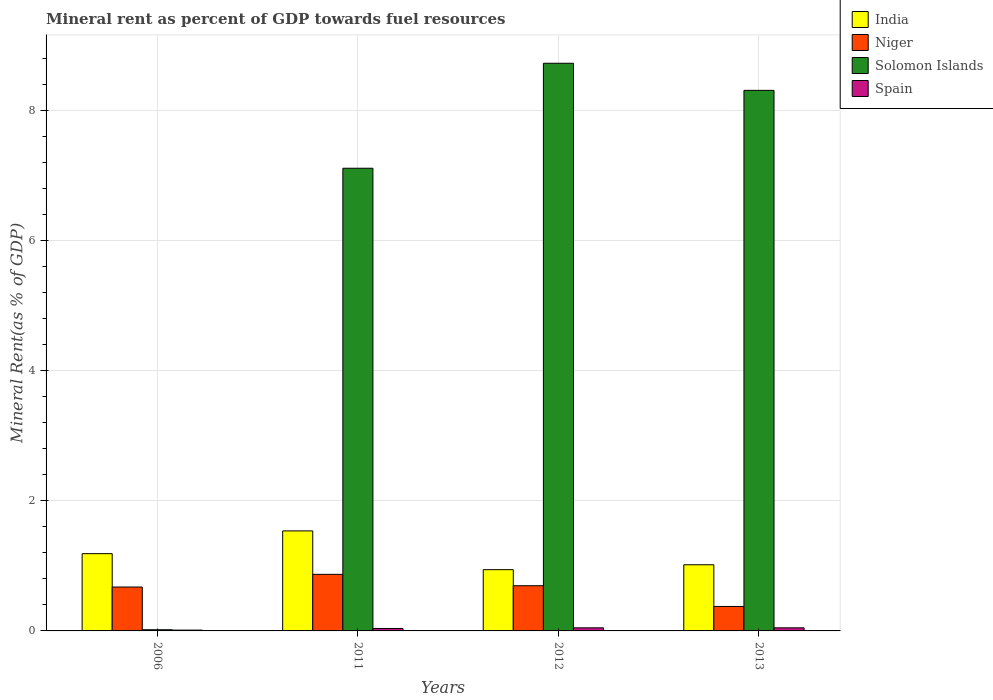How many bars are there on the 1st tick from the left?
Provide a succinct answer. 4. What is the label of the 2nd group of bars from the left?
Provide a succinct answer. 2011. In how many cases, is the number of bars for a given year not equal to the number of legend labels?
Your answer should be very brief. 0. What is the mineral rent in India in 2013?
Your answer should be very brief. 1.02. Across all years, what is the maximum mineral rent in Niger?
Your response must be concise. 0.87. Across all years, what is the minimum mineral rent in Spain?
Your answer should be compact. 0.01. In which year was the mineral rent in Niger minimum?
Provide a short and direct response. 2013. What is the total mineral rent in Niger in the graph?
Provide a short and direct response. 2.62. What is the difference between the mineral rent in Niger in 2012 and that in 2013?
Offer a very short reply. 0.32. What is the difference between the mineral rent in India in 2012 and the mineral rent in Niger in 2013?
Offer a terse response. 0.57. What is the average mineral rent in Niger per year?
Provide a short and direct response. 0.65. In the year 2012, what is the difference between the mineral rent in India and mineral rent in Niger?
Your response must be concise. 0.25. What is the ratio of the mineral rent in Niger in 2006 to that in 2011?
Keep it short and to the point. 0.78. Is the mineral rent in India in 2006 less than that in 2011?
Offer a very short reply. Yes. What is the difference between the highest and the second highest mineral rent in Spain?
Provide a succinct answer. 0. What is the difference between the highest and the lowest mineral rent in Solomon Islands?
Offer a very short reply. 8.71. Is the sum of the mineral rent in India in 2006 and 2013 greater than the maximum mineral rent in Solomon Islands across all years?
Your answer should be very brief. No. Is it the case that in every year, the sum of the mineral rent in Spain and mineral rent in Solomon Islands is greater than the sum of mineral rent in Niger and mineral rent in India?
Make the answer very short. No. What does the 3rd bar from the left in 2006 represents?
Make the answer very short. Solomon Islands. Are all the bars in the graph horizontal?
Ensure brevity in your answer.  No. How many years are there in the graph?
Provide a succinct answer. 4. Are the values on the major ticks of Y-axis written in scientific E-notation?
Your answer should be very brief. No. Does the graph contain grids?
Offer a terse response. Yes. What is the title of the graph?
Ensure brevity in your answer.  Mineral rent as percent of GDP towards fuel resources. Does "Cote d'Ivoire" appear as one of the legend labels in the graph?
Provide a succinct answer. No. What is the label or title of the Y-axis?
Give a very brief answer. Mineral Rent(as % of GDP). What is the Mineral Rent(as % of GDP) in India in 2006?
Ensure brevity in your answer.  1.19. What is the Mineral Rent(as % of GDP) of Niger in 2006?
Your response must be concise. 0.68. What is the Mineral Rent(as % of GDP) of Solomon Islands in 2006?
Your response must be concise. 0.02. What is the Mineral Rent(as % of GDP) in Spain in 2006?
Your response must be concise. 0.01. What is the Mineral Rent(as % of GDP) of India in 2011?
Your answer should be very brief. 1.54. What is the Mineral Rent(as % of GDP) of Niger in 2011?
Provide a succinct answer. 0.87. What is the Mineral Rent(as % of GDP) in Solomon Islands in 2011?
Your answer should be very brief. 7.12. What is the Mineral Rent(as % of GDP) of Spain in 2011?
Offer a terse response. 0.04. What is the Mineral Rent(as % of GDP) in India in 2012?
Offer a terse response. 0.94. What is the Mineral Rent(as % of GDP) of Niger in 2012?
Ensure brevity in your answer.  0.69. What is the Mineral Rent(as % of GDP) in Solomon Islands in 2012?
Offer a very short reply. 8.73. What is the Mineral Rent(as % of GDP) in Spain in 2012?
Keep it short and to the point. 0.05. What is the Mineral Rent(as % of GDP) of India in 2013?
Your answer should be compact. 1.02. What is the Mineral Rent(as % of GDP) in Niger in 2013?
Offer a terse response. 0.38. What is the Mineral Rent(as % of GDP) of Solomon Islands in 2013?
Offer a terse response. 8.31. What is the Mineral Rent(as % of GDP) in Spain in 2013?
Ensure brevity in your answer.  0.05. Across all years, what is the maximum Mineral Rent(as % of GDP) in India?
Keep it short and to the point. 1.54. Across all years, what is the maximum Mineral Rent(as % of GDP) of Niger?
Give a very brief answer. 0.87. Across all years, what is the maximum Mineral Rent(as % of GDP) of Solomon Islands?
Provide a succinct answer. 8.73. Across all years, what is the maximum Mineral Rent(as % of GDP) in Spain?
Give a very brief answer. 0.05. Across all years, what is the minimum Mineral Rent(as % of GDP) in India?
Offer a terse response. 0.94. Across all years, what is the minimum Mineral Rent(as % of GDP) of Niger?
Give a very brief answer. 0.38. Across all years, what is the minimum Mineral Rent(as % of GDP) of Solomon Islands?
Your answer should be very brief. 0.02. Across all years, what is the minimum Mineral Rent(as % of GDP) of Spain?
Ensure brevity in your answer.  0.01. What is the total Mineral Rent(as % of GDP) of India in the graph?
Keep it short and to the point. 4.69. What is the total Mineral Rent(as % of GDP) of Niger in the graph?
Offer a very short reply. 2.62. What is the total Mineral Rent(as % of GDP) in Solomon Islands in the graph?
Your answer should be very brief. 24.18. What is the total Mineral Rent(as % of GDP) of Spain in the graph?
Offer a terse response. 0.15. What is the difference between the Mineral Rent(as % of GDP) of India in 2006 and that in 2011?
Provide a short and direct response. -0.35. What is the difference between the Mineral Rent(as % of GDP) in Niger in 2006 and that in 2011?
Your response must be concise. -0.2. What is the difference between the Mineral Rent(as % of GDP) of Solomon Islands in 2006 and that in 2011?
Ensure brevity in your answer.  -7.1. What is the difference between the Mineral Rent(as % of GDP) of Spain in 2006 and that in 2011?
Your response must be concise. -0.03. What is the difference between the Mineral Rent(as % of GDP) in India in 2006 and that in 2012?
Provide a short and direct response. 0.25. What is the difference between the Mineral Rent(as % of GDP) in Niger in 2006 and that in 2012?
Provide a succinct answer. -0.02. What is the difference between the Mineral Rent(as % of GDP) of Solomon Islands in 2006 and that in 2012?
Your answer should be very brief. -8.71. What is the difference between the Mineral Rent(as % of GDP) in Spain in 2006 and that in 2012?
Offer a terse response. -0.04. What is the difference between the Mineral Rent(as % of GDP) in India in 2006 and that in 2013?
Your answer should be very brief. 0.17. What is the difference between the Mineral Rent(as % of GDP) in Niger in 2006 and that in 2013?
Offer a terse response. 0.3. What is the difference between the Mineral Rent(as % of GDP) in Solomon Islands in 2006 and that in 2013?
Your response must be concise. -8.3. What is the difference between the Mineral Rent(as % of GDP) in Spain in 2006 and that in 2013?
Offer a terse response. -0.03. What is the difference between the Mineral Rent(as % of GDP) of India in 2011 and that in 2012?
Your answer should be compact. 0.6. What is the difference between the Mineral Rent(as % of GDP) of Niger in 2011 and that in 2012?
Provide a succinct answer. 0.18. What is the difference between the Mineral Rent(as % of GDP) of Solomon Islands in 2011 and that in 2012?
Give a very brief answer. -1.61. What is the difference between the Mineral Rent(as % of GDP) of Spain in 2011 and that in 2012?
Provide a short and direct response. -0.01. What is the difference between the Mineral Rent(as % of GDP) of India in 2011 and that in 2013?
Provide a short and direct response. 0.52. What is the difference between the Mineral Rent(as % of GDP) of Niger in 2011 and that in 2013?
Ensure brevity in your answer.  0.49. What is the difference between the Mineral Rent(as % of GDP) of Solomon Islands in 2011 and that in 2013?
Offer a very short reply. -1.2. What is the difference between the Mineral Rent(as % of GDP) in Spain in 2011 and that in 2013?
Provide a short and direct response. -0.01. What is the difference between the Mineral Rent(as % of GDP) in India in 2012 and that in 2013?
Your answer should be compact. -0.08. What is the difference between the Mineral Rent(as % of GDP) of Niger in 2012 and that in 2013?
Offer a terse response. 0.32. What is the difference between the Mineral Rent(as % of GDP) of Solomon Islands in 2012 and that in 2013?
Make the answer very short. 0.42. What is the difference between the Mineral Rent(as % of GDP) in India in 2006 and the Mineral Rent(as % of GDP) in Niger in 2011?
Ensure brevity in your answer.  0.32. What is the difference between the Mineral Rent(as % of GDP) in India in 2006 and the Mineral Rent(as % of GDP) in Solomon Islands in 2011?
Make the answer very short. -5.93. What is the difference between the Mineral Rent(as % of GDP) in India in 2006 and the Mineral Rent(as % of GDP) in Spain in 2011?
Offer a terse response. 1.15. What is the difference between the Mineral Rent(as % of GDP) of Niger in 2006 and the Mineral Rent(as % of GDP) of Solomon Islands in 2011?
Provide a short and direct response. -6.44. What is the difference between the Mineral Rent(as % of GDP) in Niger in 2006 and the Mineral Rent(as % of GDP) in Spain in 2011?
Your answer should be compact. 0.64. What is the difference between the Mineral Rent(as % of GDP) in Solomon Islands in 2006 and the Mineral Rent(as % of GDP) in Spain in 2011?
Offer a terse response. -0.02. What is the difference between the Mineral Rent(as % of GDP) in India in 2006 and the Mineral Rent(as % of GDP) in Niger in 2012?
Offer a terse response. 0.49. What is the difference between the Mineral Rent(as % of GDP) in India in 2006 and the Mineral Rent(as % of GDP) in Solomon Islands in 2012?
Give a very brief answer. -7.54. What is the difference between the Mineral Rent(as % of GDP) of India in 2006 and the Mineral Rent(as % of GDP) of Spain in 2012?
Ensure brevity in your answer.  1.14. What is the difference between the Mineral Rent(as % of GDP) in Niger in 2006 and the Mineral Rent(as % of GDP) in Solomon Islands in 2012?
Provide a succinct answer. -8.06. What is the difference between the Mineral Rent(as % of GDP) in Niger in 2006 and the Mineral Rent(as % of GDP) in Spain in 2012?
Give a very brief answer. 0.63. What is the difference between the Mineral Rent(as % of GDP) of Solomon Islands in 2006 and the Mineral Rent(as % of GDP) of Spain in 2012?
Your answer should be very brief. -0.03. What is the difference between the Mineral Rent(as % of GDP) in India in 2006 and the Mineral Rent(as % of GDP) in Niger in 2013?
Your response must be concise. 0.81. What is the difference between the Mineral Rent(as % of GDP) of India in 2006 and the Mineral Rent(as % of GDP) of Solomon Islands in 2013?
Provide a short and direct response. -7.13. What is the difference between the Mineral Rent(as % of GDP) in India in 2006 and the Mineral Rent(as % of GDP) in Spain in 2013?
Offer a terse response. 1.14. What is the difference between the Mineral Rent(as % of GDP) of Niger in 2006 and the Mineral Rent(as % of GDP) of Solomon Islands in 2013?
Your answer should be very brief. -7.64. What is the difference between the Mineral Rent(as % of GDP) in Niger in 2006 and the Mineral Rent(as % of GDP) in Spain in 2013?
Your answer should be compact. 0.63. What is the difference between the Mineral Rent(as % of GDP) of Solomon Islands in 2006 and the Mineral Rent(as % of GDP) of Spain in 2013?
Your response must be concise. -0.03. What is the difference between the Mineral Rent(as % of GDP) of India in 2011 and the Mineral Rent(as % of GDP) of Niger in 2012?
Give a very brief answer. 0.84. What is the difference between the Mineral Rent(as % of GDP) in India in 2011 and the Mineral Rent(as % of GDP) in Solomon Islands in 2012?
Your answer should be compact. -7.19. What is the difference between the Mineral Rent(as % of GDP) in India in 2011 and the Mineral Rent(as % of GDP) in Spain in 2012?
Keep it short and to the point. 1.49. What is the difference between the Mineral Rent(as % of GDP) of Niger in 2011 and the Mineral Rent(as % of GDP) of Solomon Islands in 2012?
Your answer should be compact. -7.86. What is the difference between the Mineral Rent(as % of GDP) in Niger in 2011 and the Mineral Rent(as % of GDP) in Spain in 2012?
Offer a very short reply. 0.82. What is the difference between the Mineral Rent(as % of GDP) in Solomon Islands in 2011 and the Mineral Rent(as % of GDP) in Spain in 2012?
Your response must be concise. 7.07. What is the difference between the Mineral Rent(as % of GDP) in India in 2011 and the Mineral Rent(as % of GDP) in Niger in 2013?
Offer a terse response. 1.16. What is the difference between the Mineral Rent(as % of GDP) in India in 2011 and the Mineral Rent(as % of GDP) in Solomon Islands in 2013?
Offer a very short reply. -6.78. What is the difference between the Mineral Rent(as % of GDP) in India in 2011 and the Mineral Rent(as % of GDP) in Spain in 2013?
Offer a very short reply. 1.49. What is the difference between the Mineral Rent(as % of GDP) of Niger in 2011 and the Mineral Rent(as % of GDP) of Solomon Islands in 2013?
Make the answer very short. -7.44. What is the difference between the Mineral Rent(as % of GDP) of Niger in 2011 and the Mineral Rent(as % of GDP) of Spain in 2013?
Provide a short and direct response. 0.82. What is the difference between the Mineral Rent(as % of GDP) of Solomon Islands in 2011 and the Mineral Rent(as % of GDP) of Spain in 2013?
Offer a terse response. 7.07. What is the difference between the Mineral Rent(as % of GDP) of India in 2012 and the Mineral Rent(as % of GDP) of Niger in 2013?
Keep it short and to the point. 0.57. What is the difference between the Mineral Rent(as % of GDP) of India in 2012 and the Mineral Rent(as % of GDP) of Solomon Islands in 2013?
Provide a succinct answer. -7.37. What is the difference between the Mineral Rent(as % of GDP) in India in 2012 and the Mineral Rent(as % of GDP) in Spain in 2013?
Your response must be concise. 0.89. What is the difference between the Mineral Rent(as % of GDP) in Niger in 2012 and the Mineral Rent(as % of GDP) in Solomon Islands in 2013?
Keep it short and to the point. -7.62. What is the difference between the Mineral Rent(as % of GDP) in Niger in 2012 and the Mineral Rent(as % of GDP) in Spain in 2013?
Provide a short and direct response. 0.65. What is the difference between the Mineral Rent(as % of GDP) of Solomon Islands in 2012 and the Mineral Rent(as % of GDP) of Spain in 2013?
Provide a succinct answer. 8.68. What is the average Mineral Rent(as % of GDP) in India per year?
Provide a short and direct response. 1.17. What is the average Mineral Rent(as % of GDP) in Niger per year?
Your answer should be very brief. 0.65. What is the average Mineral Rent(as % of GDP) of Solomon Islands per year?
Make the answer very short. 6.04. What is the average Mineral Rent(as % of GDP) in Spain per year?
Ensure brevity in your answer.  0.04. In the year 2006, what is the difference between the Mineral Rent(as % of GDP) of India and Mineral Rent(as % of GDP) of Niger?
Provide a short and direct response. 0.51. In the year 2006, what is the difference between the Mineral Rent(as % of GDP) in India and Mineral Rent(as % of GDP) in Solomon Islands?
Your answer should be compact. 1.17. In the year 2006, what is the difference between the Mineral Rent(as % of GDP) in India and Mineral Rent(as % of GDP) in Spain?
Your answer should be compact. 1.18. In the year 2006, what is the difference between the Mineral Rent(as % of GDP) of Niger and Mineral Rent(as % of GDP) of Solomon Islands?
Give a very brief answer. 0.66. In the year 2006, what is the difference between the Mineral Rent(as % of GDP) in Niger and Mineral Rent(as % of GDP) in Spain?
Ensure brevity in your answer.  0.66. In the year 2006, what is the difference between the Mineral Rent(as % of GDP) in Solomon Islands and Mineral Rent(as % of GDP) in Spain?
Give a very brief answer. 0.01. In the year 2011, what is the difference between the Mineral Rent(as % of GDP) in India and Mineral Rent(as % of GDP) in Niger?
Provide a short and direct response. 0.67. In the year 2011, what is the difference between the Mineral Rent(as % of GDP) in India and Mineral Rent(as % of GDP) in Solomon Islands?
Make the answer very short. -5.58. In the year 2011, what is the difference between the Mineral Rent(as % of GDP) in India and Mineral Rent(as % of GDP) in Spain?
Keep it short and to the point. 1.5. In the year 2011, what is the difference between the Mineral Rent(as % of GDP) in Niger and Mineral Rent(as % of GDP) in Solomon Islands?
Offer a very short reply. -6.25. In the year 2011, what is the difference between the Mineral Rent(as % of GDP) in Niger and Mineral Rent(as % of GDP) in Spain?
Your response must be concise. 0.83. In the year 2011, what is the difference between the Mineral Rent(as % of GDP) in Solomon Islands and Mineral Rent(as % of GDP) in Spain?
Your response must be concise. 7.08. In the year 2012, what is the difference between the Mineral Rent(as % of GDP) of India and Mineral Rent(as % of GDP) of Niger?
Offer a terse response. 0.25. In the year 2012, what is the difference between the Mineral Rent(as % of GDP) of India and Mineral Rent(as % of GDP) of Solomon Islands?
Keep it short and to the point. -7.79. In the year 2012, what is the difference between the Mineral Rent(as % of GDP) in India and Mineral Rent(as % of GDP) in Spain?
Ensure brevity in your answer.  0.89. In the year 2012, what is the difference between the Mineral Rent(as % of GDP) of Niger and Mineral Rent(as % of GDP) of Solomon Islands?
Your answer should be compact. -8.04. In the year 2012, what is the difference between the Mineral Rent(as % of GDP) of Niger and Mineral Rent(as % of GDP) of Spain?
Keep it short and to the point. 0.65. In the year 2012, what is the difference between the Mineral Rent(as % of GDP) of Solomon Islands and Mineral Rent(as % of GDP) of Spain?
Provide a short and direct response. 8.68. In the year 2013, what is the difference between the Mineral Rent(as % of GDP) in India and Mineral Rent(as % of GDP) in Niger?
Ensure brevity in your answer.  0.64. In the year 2013, what is the difference between the Mineral Rent(as % of GDP) in India and Mineral Rent(as % of GDP) in Solomon Islands?
Provide a succinct answer. -7.3. In the year 2013, what is the difference between the Mineral Rent(as % of GDP) of India and Mineral Rent(as % of GDP) of Spain?
Provide a short and direct response. 0.97. In the year 2013, what is the difference between the Mineral Rent(as % of GDP) in Niger and Mineral Rent(as % of GDP) in Solomon Islands?
Your answer should be very brief. -7.94. In the year 2013, what is the difference between the Mineral Rent(as % of GDP) in Niger and Mineral Rent(as % of GDP) in Spain?
Give a very brief answer. 0.33. In the year 2013, what is the difference between the Mineral Rent(as % of GDP) in Solomon Islands and Mineral Rent(as % of GDP) in Spain?
Keep it short and to the point. 8.27. What is the ratio of the Mineral Rent(as % of GDP) of India in 2006 to that in 2011?
Give a very brief answer. 0.77. What is the ratio of the Mineral Rent(as % of GDP) in Niger in 2006 to that in 2011?
Your response must be concise. 0.78. What is the ratio of the Mineral Rent(as % of GDP) of Solomon Islands in 2006 to that in 2011?
Offer a terse response. 0. What is the ratio of the Mineral Rent(as % of GDP) of Spain in 2006 to that in 2011?
Your response must be concise. 0.33. What is the ratio of the Mineral Rent(as % of GDP) of India in 2006 to that in 2012?
Give a very brief answer. 1.26. What is the ratio of the Mineral Rent(as % of GDP) of Niger in 2006 to that in 2012?
Your answer should be very brief. 0.97. What is the ratio of the Mineral Rent(as % of GDP) in Solomon Islands in 2006 to that in 2012?
Keep it short and to the point. 0. What is the ratio of the Mineral Rent(as % of GDP) of Spain in 2006 to that in 2012?
Keep it short and to the point. 0.26. What is the ratio of the Mineral Rent(as % of GDP) of India in 2006 to that in 2013?
Provide a succinct answer. 1.17. What is the ratio of the Mineral Rent(as % of GDP) in Niger in 2006 to that in 2013?
Keep it short and to the point. 1.8. What is the ratio of the Mineral Rent(as % of GDP) of Solomon Islands in 2006 to that in 2013?
Ensure brevity in your answer.  0. What is the ratio of the Mineral Rent(as % of GDP) in Spain in 2006 to that in 2013?
Offer a terse response. 0.27. What is the ratio of the Mineral Rent(as % of GDP) of India in 2011 to that in 2012?
Your answer should be very brief. 1.63. What is the ratio of the Mineral Rent(as % of GDP) in Niger in 2011 to that in 2012?
Keep it short and to the point. 1.25. What is the ratio of the Mineral Rent(as % of GDP) in Solomon Islands in 2011 to that in 2012?
Your answer should be compact. 0.82. What is the ratio of the Mineral Rent(as % of GDP) in Spain in 2011 to that in 2012?
Offer a very short reply. 0.79. What is the ratio of the Mineral Rent(as % of GDP) in India in 2011 to that in 2013?
Make the answer very short. 1.51. What is the ratio of the Mineral Rent(as % of GDP) in Niger in 2011 to that in 2013?
Provide a succinct answer. 2.31. What is the ratio of the Mineral Rent(as % of GDP) of Solomon Islands in 2011 to that in 2013?
Your response must be concise. 0.86. What is the ratio of the Mineral Rent(as % of GDP) of Spain in 2011 to that in 2013?
Provide a succinct answer. 0.79. What is the ratio of the Mineral Rent(as % of GDP) of India in 2012 to that in 2013?
Your response must be concise. 0.93. What is the ratio of the Mineral Rent(as % of GDP) of Niger in 2012 to that in 2013?
Provide a succinct answer. 1.85. What is the ratio of the Mineral Rent(as % of GDP) of Solomon Islands in 2012 to that in 2013?
Keep it short and to the point. 1.05. What is the ratio of the Mineral Rent(as % of GDP) of Spain in 2012 to that in 2013?
Your answer should be very brief. 1.01. What is the difference between the highest and the second highest Mineral Rent(as % of GDP) of India?
Your response must be concise. 0.35. What is the difference between the highest and the second highest Mineral Rent(as % of GDP) in Niger?
Keep it short and to the point. 0.18. What is the difference between the highest and the second highest Mineral Rent(as % of GDP) of Solomon Islands?
Your answer should be very brief. 0.42. What is the difference between the highest and the lowest Mineral Rent(as % of GDP) of India?
Your answer should be very brief. 0.6. What is the difference between the highest and the lowest Mineral Rent(as % of GDP) of Niger?
Keep it short and to the point. 0.49. What is the difference between the highest and the lowest Mineral Rent(as % of GDP) in Solomon Islands?
Provide a succinct answer. 8.71. What is the difference between the highest and the lowest Mineral Rent(as % of GDP) of Spain?
Your answer should be compact. 0.04. 